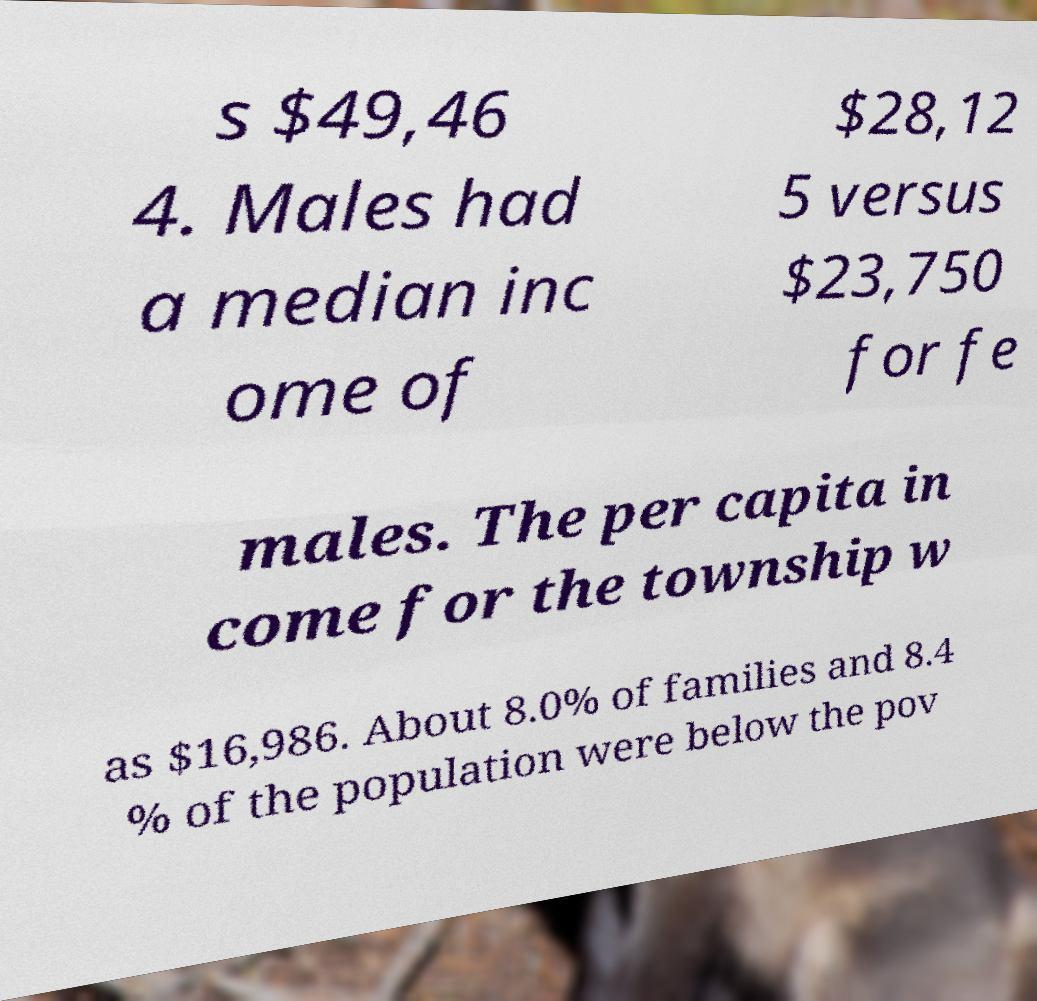There's text embedded in this image that I need extracted. Can you transcribe it verbatim? s $49,46 4. Males had a median inc ome of $28,12 5 versus $23,750 for fe males. The per capita in come for the township w as $16,986. About 8.0% of families and 8.4 % of the population were below the pov 